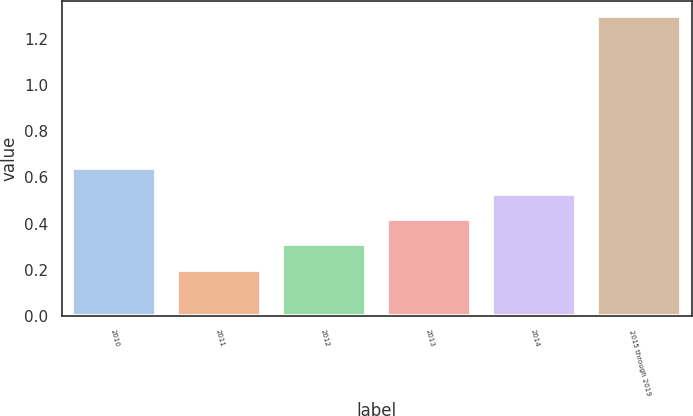<chart> <loc_0><loc_0><loc_500><loc_500><bar_chart><fcel>2010<fcel>2011<fcel>2012<fcel>2013<fcel>2014<fcel>2015 through 2019<nl><fcel>0.64<fcel>0.2<fcel>0.31<fcel>0.42<fcel>0.53<fcel>1.3<nl></chart> 